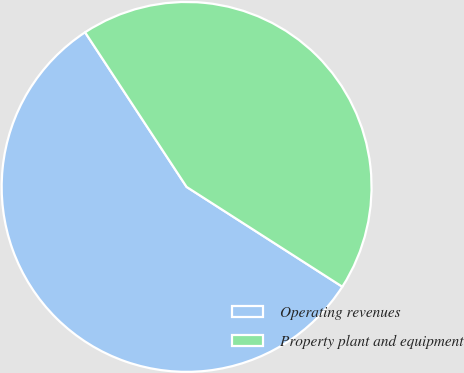Convert chart. <chart><loc_0><loc_0><loc_500><loc_500><pie_chart><fcel>Operating revenues<fcel>Property plant and equipment<nl><fcel>56.68%<fcel>43.32%<nl></chart> 